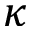Convert formula to latex. <formula><loc_0><loc_0><loc_500><loc_500>\kappa</formula> 